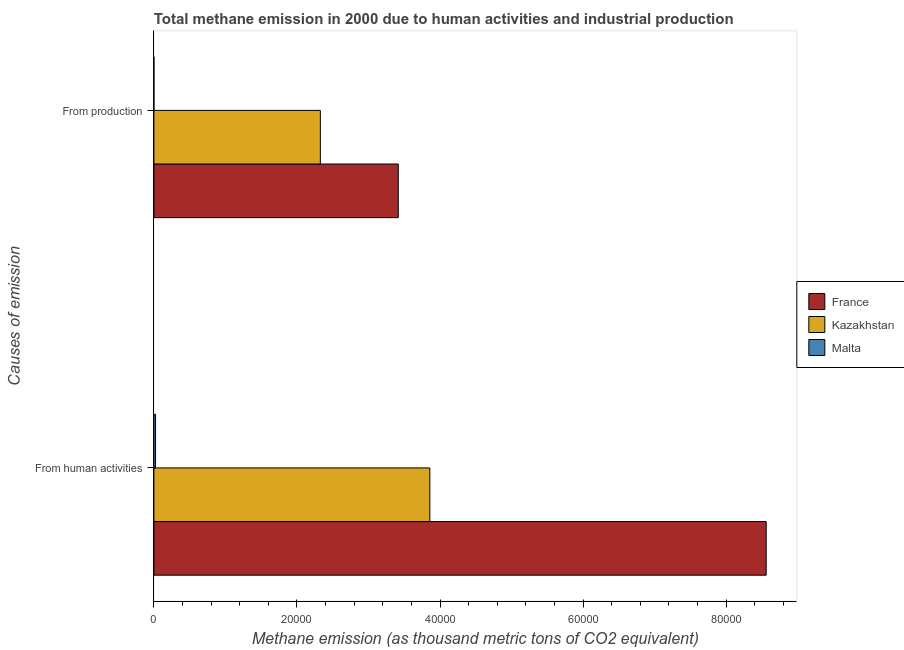Are the number of bars per tick equal to the number of legend labels?
Provide a short and direct response. Yes. What is the label of the 1st group of bars from the top?
Ensure brevity in your answer.  From production. What is the amount of emissions generated from industries in Malta?
Keep it short and to the point. 2.3. Across all countries, what is the maximum amount of emissions generated from industries?
Your answer should be very brief. 3.42e+04. Across all countries, what is the minimum amount of emissions from human activities?
Your answer should be very brief. 230.8. In which country was the amount of emissions generated from industries minimum?
Offer a terse response. Malta. What is the total amount of emissions generated from industries in the graph?
Offer a very short reply. 5.74e+04. What is the difference between the amount of emissions from human activities in Kazakhstan and that in France?
Your answer should be compact. -4.70e+04. What is the difference between the amount of emissions from human activities in Malta and the amount of emissions generated from industries in Kazakhstan?
Ensure brevity in your answer.  -2.30e+04. What is the average amount of emissions from human activities per country?
Your response must be concise. 4.15e+04. What is the difference between the amount of emissions generated from industries and amount of emissions from human activities in Malta?
Make the answer very short. -228.5. In how many countries, is the amount of emissions generated from industries greater than 64000 thousand metric tons?
Your answer should be compact. 0. What is the ratio of the amount of emissions from human activities in France to that in Kazakhstan?
Provide a succinct answer. 2.22. In how many countries, is the amount of emissions from human activities greater than the average amount of emissions from human activities taken over all countries?
Provide a succinct answer. 1. What does the 2nd bar from the top in From production represents?
Your answer should be compact. Kazakhstan. What does the 3rd bar from the bottom in From human activities represents?
Keep it short and to the point. Malta. How many bars are there?
Provide a short and direct response. 6. Are the values on the major ticks of X-axis written in scientific E-notation?
Offer a very short reply. No. Does the graph contain any zero values?
Your response must be concise. No. Does the graph contain grids?
Ensure brevity in your answer.  No. Where does the legend appear in the graph?
Keep it short and to the point. Center right. What is the title of the graph?
Offer a terse response. Total methane emission in 2000 due to human activities and industrial production. What is the label or title of the X-axis?
Provide a short and direct response. Methane emission (as thousand metric tons of CO2 equivalent). What is the label or title of the Y-axis?
Provide a succinct answer. Causes of emission. What is the Methane emission (as thousand metric tons of CO2 equivalent) in France in From human activities?
Offer a very short reply. 8.56e+04. What is the Methane emission (as thousand metric tons of CO2 equivalent) in Kazakhstan in From human activities?
Offer a terse response. 3.86e+04. What is the Methane emission (as thousand metric tons of CO2 equivalent) of Malta in From human activities?
Keep it short and to the point. 230.8. What is the Methane emission (as thousand metric tons of CO2 equivalent) in France in From production?
Ensure brevity in your answer.  3.42e+04. What is the Methane emission (as thousand metric tons of CO2 equivalent) of Kazakhstan in From production?
Your response must be concise. 2.33e+04. Across all Causes of emission, what is the maximum Methane emission (as thousand metric tons of CO2 equivalent) in France?
Keep it short and to the point. 8.56e+04. Across all Causes of emission, what is the maximum Methane emission (as thousand metric tons of CO2 equivalent) in Kazakhstan?
Offer a very short reply. 3.86e+04. Across all Causes of emission, what is the maximum Methane emission (as thousand metric tons of CO2 equivalent) in Malta?
Offer a terse response. 230.8. Across all Causes of emission, what is the minimum Methane emission (as thousand metric tons of CO2 equivalent) in France?
Provide a short and direct response. 3.42e+04. Across all Causes of emission, what is the minimum Methane emission (as thousand metric tons of CO2 equivalent) of Kazakhstan?
Your response must be concise. 2.33e+04. Across all Causes of emission, what is the minimum Methane emission (as thousand metric tons of CO2 equivalent) in Malta?
Your answer should be compact. 2.3. What is the total Methane emission (as thousand metric tons of CO2 equivalent) in France in the graph?
Your answer should be very brief. 1.20e+05. What is the total Methane emission (as thousand metric tons of CO2 equivalent) in Kazakhstan in the graph?
Make the answer very short. 6.18e+04. What is the total Methane emission (as thousand metric tons of CO2 equivalent) of Malta in the graph?
Keep it short and to the point. 233.1. What is the difference between the Methane emission (as thousand metric tons of CO2 equivalent) in France in From human activities and that in From production?
Your response must be concise. 5.14e+04. What is the difference between the Methane emission (as thousand metric tons of CO2 equivalent) in Kazakhstan in From human activities and that in From production?
Ensure brevity in your answer.  1.53e+04. What is the difference between the Methane emission (as thousand metric tons of CO2 equivalent) of Malta in From human activities and that in From production?
Your answer should be very brief. 228.5. What is the difference between the Methane emission (as thousand metric tons of CO2 equivalent) of France in From human activities and the Methane emission (as thousand metric tons of CO2 equivalent) of Kazakhstan in From production?
Ensure brevity in your answer.  6.23e+04. What is the difference between the Methane emission (as thousand metric tons of CO2 equivalent) of France in From human activities and the Methane emission (as thousand metric tons of CO2 equivalent) of Malta in From production?
Your answer should be very brief. 8.56e+04. What is the difference between the Methane emission (as thousand metric tons of CO2 equivalent) of Kazakhstan in From human activities and the Methane emission (as thousand metric tons of CO2 equivalent) of Malta in From production?
Keep it short and to the point. 3.86e+04. What is the average Methane emission (as thousand metric tons of CO2 equivalent) of France per Causes of emission?
Offer a terse response. 5.99e+04. What is the average Methane emission (as thousand metric tons of CO2 equivalent) in Kazakhstan per Causes of emission?
Your answer should be compact. 3.09e+04. What is the average Methane emission (as thousand metric tons of CO2 equivalent) of Malta per Causes of emission?
Your response must be concise. 116.55. What is the difference between the Methane emission (as thousand metric tons of CO2 equivalent) of France and Methane emission (as thousand metric tons of CO2 equivalent) of Kazakhstan in From human activities?
Provide a succinct answer. 4.70e+04. What is the difference between the Methane emission (as thousand metric tons of CO2 equivalent) in France and Methane emission (as thousand metric tons of CO2 equivalent) in Malta in From human activities?
Keep it short and to the point. 8.54e+04. What is the difference between the Methane emission (as thousand metric tons of CO2 equivalent) of Kazakhstan and Methane emission (as thousand metric tons of CO2 equivalent) of Malta in From human activities?
Your answer should be compact. 3.83e+04. What is the difference between the Methane emission (as thousand metric tons of CO2 equivalent) of France and Methane emission (as thousand metric tons of CO2 equivalent) of Kazakhstan in From production?
Your response must be concise. 1.09e+04. What is the difference between the Methane emission (as thousand metric tons of CO2 equivalent) in France and Methane emission (as thousand metric tons of CO2 equivalent) in Malta in From production?
Your answer should be very brief. 3.42e+04. What is the difference between the Methane emission (as thousand metric tons of CO2 equivalent) in Kazakhstan and Methane emission (as thousand metric tons of CO2 equivalent) in Malta in From production?
Offer a terse response. 2.33e+04. What is the ratio of the Methane emission (as thousand metric tons of CO2 equivalent) in France in From human activities to that in From production?
Offer a very short reply. 2.51. What is the ratio of the Methane emission (as thousand metric tons of CO2 equivalent) of Kazakhstan in From human activities to that in From production?
Your answer should be compact. 1.66. What is the ratio of the Methane emission (as thousand metric tons of CO2 equivalent) of Malta in From human activities to that in From production?
Offer a very short reply. 100.35. What is the difference between the highest and the second highest Methane emission (as thousand metric tons of CO2 equivalent) of France?
Offer a very short reply. 5.14e+04. What is the difference between the highest and the second highest Methane emission (as thousand metric tons of CO2 equivalent) of Kazakhstan?
Give a very brief answer. 1.53e+04. What is the difference between the highest and the second highest Methane emission (as thousand metric tons of CO2 equivalent) in Malta?
Your answer should be very brief. 228.5. What is the difference between the highest and the lowest Methane emission (as thousand metric tons of CO2 equivalent) of France?
Your response must be concise. 5.14e+04. What is the difference between the highest and the lowest Methane emission (as thousand metric tons of CO2 equivalent) in Kazakhstan?
Provide a succinct answer. 1.53e+04. What is the difference between the highest and the lowest Methane emission (as thousand metric tons of CO2 equivalent) in Malta?
Your answer should be compact. 228.5. 